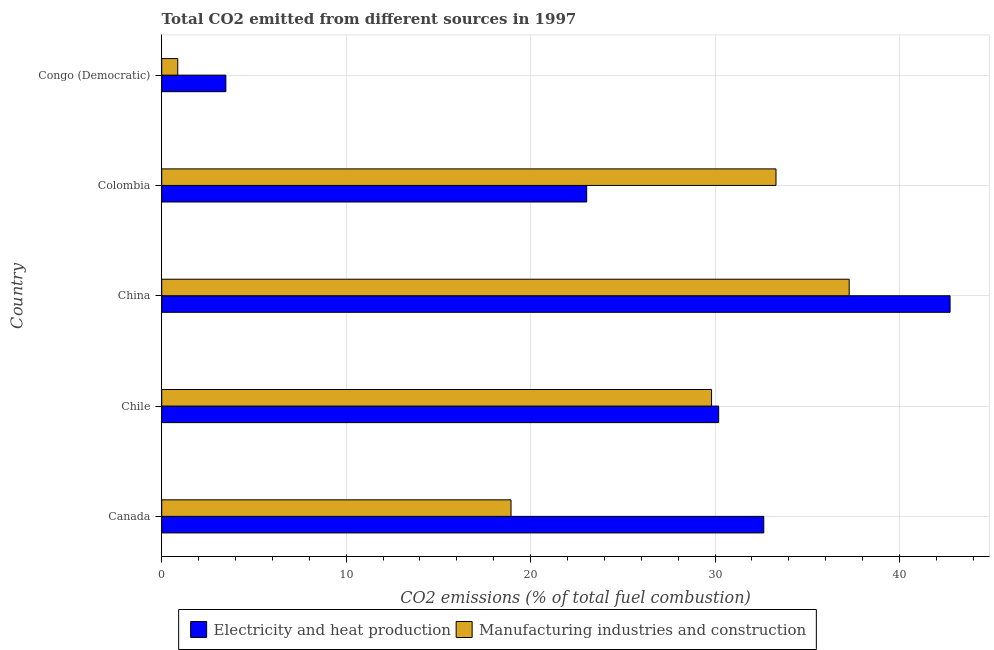How many different coloured bars are there?
Provide a short and direct response. 2. Are the number of bars per tick equal to the number of legend labels?
Keep it short and to the point. Yes. What is the co2 emissions due to manufacturing industries in Colombia?
Your response must be concise. 33.31. Across all countries, what is the maximum co2 emissions due to electricity and heat production?
Provide a short and direct response. 42.74. Across all countries, what is the minimum co2 emissions due to electricity and heat production?
Provide a short and direct response. 3.48. In which country was the co2 emissions due to electricity and heat production minimum?
Keep it short and to the point. Congo (Democratic). What is the total co2 emissions due to electricity and heat production in the graph?
Keep it short and to the point. 132.11. What is the difference between the co2 emissions due to electricity and heat production in Chile and that in China?
Your answer should be compact. -12.55. What is the difference between the co2 emissions due to electricity and heat production in Congo (Democratic) and the co2 emissions due to manufacturing industries in Canada?
Offer a terse response. -15.46. What is the average co2 emissions due to manufacturing industries per country?
Offer a very short reply. 24.04. What is the difference between the co2 emissions due to manufacturing industries and co2 emissions due to electricity and heat production in Colombia?
Offer a very short reply. 10.26. What is the ratio of the co2 emissions due to electricity and heat production in China to that in Congo (Democratic)?
Offer a terse response. 12.29. What is the difference between the highest and the second highest co2 emissions due to manufacturing industries?
Your answer should be compact. 3.97. What is the difference between the highest and the lowest co2 emissions due to manufacturing industries?
Provide a succinct answer. 36.41. What does the 2nd bar from the top in Colombia represents?
Ensure brevity in your answer.  Electricity and heat production. What does the 2nd bar from the bottom in Colombia represents?
Make the answer very short. Manufacturing industries and construction. How many bars are there?
Your response must be concise. 10. How many countries are there in the graph?
Your response must be concise. 5. Are the values on the major ticks of X-axis written in scientific E-notation?
Provide a short and direct response. No. Does the graph contain any zero values?
Your response must be concise. No. How many legend labels are there?
Your answer should be very brief. 2. What is the title of the graph?
Your answer should be very brief. Total CO2 emitted from different sources in 1997. What is the label or title of the X-axis?
Your answer should be compact. CO2 emissions (% of total fuel combustion). What is the CO2 emissions (% of total fuel combustion) of Electricity and heat production in Canada?
Ensure brevity in your answer.  32.64. What is the CO2 emissions (% of total fuel combustion) of Manufacturing industries and construction in Canada?
Offer a very short reply. 18.94. What is the CO2 emissions (% of total fuel combustion) in Electricity and heat production in Chile?
Your response must be concise. 30.2. What is the CO2 emissions (% of total fuel combustion) of Manufacturing industries and construction in Chile?
Provide a short and direct response. 29.81. What is the CO2 emissions (% of total fuel combustion) in Electricity and heat production in China?
Keep it short and to the point. 42.74. What is the CO2 emissions (% of total fuel combustion) in Manufacturing industries and construction in China?
Your answer should be very brief. 37.27. What is the CO2 emissions (% of total fuel combustion) of Electricity and heat production in Colombia?
Make the answer very short. 23.04. What is the CO2 emissions (% of total fuel combustion) in Manufacturing industries and construction in Colombia?
Provide a short and direct response. 33.31. What is the CO2 emissions (% of total fuel combustion) of Electricity and heat production in Congo (Democratic)?
Provide a succinct answer. 3.48. What is the CO2 emissions (% of total fuel combustion) of Manufacturing industries and construction in Congo (Democratic)?
Your response must be concise. 0.87. Across all countries, what is the maximum CO2 emissions (% of total fuel combustion) of Electricity and heat production?
Make the answer very short. 42.74. Across all countries, what is the maximum CO2 emissions (% of total fuel combustion) of Manufacturing industries and construction?
Give a very brief answer. 37.27. Across all countries, what is the minimum CO2 emissions (% of total fuel combustion) in Electricity and heat production?
Your response must be concise. 3.48. Across all countries, what is the minimum CO2 emissions (% of total fuel combustion) in Manufacturing industries and construction?
Provide a short and direct response. 0.87. What is the total CO2 emissions (% of total fuel combustion) in Electricity and heat production in the graph?
Provide a succinct answer. 132.11. What is the total CO2 emissions (% of total fuel combustion) in Manufacturing industries and construction in the graph?
Offer a very short reply. 120.2. What is the difference between the CO2 emissions (% of total fuel combustion) in Electricity and heat production in Canada and that in Chile?
Provide a short and direct response. 2.45. What is the difference between the CO2 emissions (% of total fuel combustion) of Manufacturing industries and construction in Canada and that in Chile?
Your answer should be very brief. -10.87. What is the difference between the CO2 emissions (% of total fuel combustion) in Electricity and heat production in Canada and that in China?
Offer a terse response. -10.1. What is the difference between the CO2 emissions (% of total fuel combustion) of Manufacturing industries and construction in Canada and that in China?
Your answer should be compact. -18.34. What is the difference between the CO2 emissions (% of total fuel combustion) in Electricity and heat production in Canada and that in Colombia?
Your response must be concise. 9.6. What is the difference between the CO2 emissions (% of total fuel combustion) in Manufacturing industries and construction in Canada and that in Colombia?
Your answer should be very brief. -14.37. What is the difference between the CO2 emissions (% of total fuel combustion) in Electricity and heat production in Canada and that in Congo (Democratic)?
Keep it short and to the point. 29.17. What is the difference between the CO2 emissions (% of total fuel combustion) of Manufacturing industries and construction in Canada and that in Congo (Democratic)?
Keep it short and to the point. 18.07. What is the difference between the CO2 emissions (% of total fuel combustion) in Electricity and heat production in Chile and that in China?
Give a very brief answer. -12.55. What is the difference between the CO2 emissions (% of total fuel combustion) of Manufacturing industries and construction in Chile and that in China?
Provide a short and direct response. -7.46. What is the difference between the CO2 emissions (% of total fuel combustion) in Electricity and heat production in Chile and that in Colombia?
Give a very brief answer. 7.16. What is the difference between the CO2 emissions (% of total fuel combustion) of Manufacturing industries and construction in Chile and that in Colombia?
Your answer should be compact. -3.49. What is the difference between the CO2 emissions (% of total fuel combustion) in Electricity and heat production in Chile and that in Congo (Democratic)?
Keep it short and to the point. 26.72. What is the difference between the CO2 emissions (% of total fuel combustion) in Manufacturing industries and construction in Chile and that in Congo (Democratic)?
Ensure brevity in your answer.  28.94. What is the difference between the CO2 emissions (% of total fuel combustion) in Electricity and heat production in China and that in Colombia?
Keep it short and to the point. 19.7. What is the difference between the CO2 emissions (% of total fuel combustion) of Manufacturing industries and construction in China and that in Colombia?
Your answer should be very brief. 3.97. What is the difference between the CO2 emissions (% of total fuel combustion) in Electricity and heat production in China and that in Congo (Democratic)?
Give a very brief answer. 39.27. What is the difference between the CO2 emissions (% of total fuel combustion) of Manufacturing industries and construction in China and that in Congo (Democratic)?
Offer a very short reply. 36.41. What is the difference between the CO2 emissions (% of total fuel combustion) of Electricity and heat production in Colombia and that in Congo (Democratic)?
Give a very brief answer. 19.56. What is the difference between the CO2 emissions (% of total fuel combustion) of Manufacturing industries and construction in Colombia and that in Congo (Democratic)?
Your response must be concise. 32.44. What is the difference between the CO2 emissions (% of total fuel combustion) of Electricity and heat production in Canada and the CO2 emissions (% of total fuel combustion) of Manufacturing industries and construction in Chile?
Keep it short and to the point. 2.83. What is the difference between the CO2 emissions (% of total fuel combustion) in Electricity and heat production in Canada and the CO2 emissions (% of total fuel combustion) in Manufacturing industries and construction in China?
Offer a very short reply. -4.63. What is the difference between the CO2 emissions (% of total fuel combustion) of Electricity and heat production in Canada and the CO2 emissions (% of total fuel combustion) of Manufacturing industries and construction in Colombia?
Your answer should be compact. -0.66. What is the difference between the CO2 emissions (% of total fuel combustion) in Electricity and heat production in Canada and the CO2 emissions (% of total fuel combustion) in Manufacturing industries and construction in Congo (Democratic)?
Offer a terse response. 31.77. What is the difference between the CO2 emissions (% of total fuel combustion) in Electricity and heat production in Chile and the CO2 emissions (% of total fuel combustion) in Manufacturing industries and construction in China?
Offer a very short reply. -7.08. What is the difference between the CO2 emissions (% of total fuel combustion) in Electricity and heat production in Chile and the CO2 emissions (% of total fuel combustion) in Manufacturing industries and construction in Colombia?
Your response must be concise. -3.11. What is the difference between the CO2 emissions (% of total fuel combustion) in Electricity and heat production in Chile and the CO2 emissions (% of total fuel combustion) in Manufacturing industries and construction in Congo (Democratic)?
Your answer should be compact. 29.33. What is the difference between the CO2 emissions (% of total fuel combustion) in Electricity and heat production in China and the CO2 emissions (% of total fuel combustion) in Manufacturing industries and construction in Colombia?
Your response must be concise. 9.44. What is the difference between the CO2 emissions (% of total fuel combustion) in Electricity and heat production in China and the CO2 emissions (% of total fuel combustion) in Manufacturing industries and construction in Congo (Democratic)?
Provide a short and direct response. 41.88. What is the difference between the CO2 emissions (% of total fuel combustion) of Electricity and heat production in Colombia and the CO2 emissions (% of total fuel combustion) of Manufacturing industries and construction in Congo (Democratic)?
Offer a terse response. 22.17. What is the average CO2 emissions (% of total fuel combustion) of Electricity and heat production per country?
Your response must be concise. 26.42. What is the average CO2 emissions (% of total fuel combustion) of Manufacturing industries and construction per country?
Offer a very short reply. 24.04. What is the difference between the CO2 emissions (% of total fuel combustion) in Electricity and heat production and CO2 emissions (% of total fuel combustion) in Manufacturing industries and construction in Canada?
Give a very brief answer. 13.7. What is the difference between the CO2 emissions (% of total fuel combustion) in Electricity and heat production and CO2 emissions (% of total fuel combustion) in Manufacturing industries and construction in Chile?
Offer a very short reply. 0.39. What is the difference between the CO2 emissions (% of total fuel combustion) of Electricity and heat production and CO2 emissions (% of total fuel combustion) of Manufacturing industries and construction in China?
Provide a succinct answer. 5.47. What is the difference between the CO2 emissions (% of total fuel combustion) of Electricity and heat production and CO2 emissions (% of total fuel combustion) of Manufacturing industries and construction in Colombia?
Your response must be concise. -10.26. What is the difference between the CO2 emissions (% of total fuel combustion) of Electricity and heat production and CO2 emissions (% of total fuel combustion) of Manufacturing industries and construction in Congo (Democratic)?
Keep it short and to the point. 2.61. What is the ratio of the CO2 emissions (% of total fuel combustion) of Electricity and heat production in Canada to that in Chile?
Offer a terse response. 1.08. What is the ratio of the CO2 emissions (% of total fuel combustion) of Manufacturing industries and construction in Canada to that in Chile?
Offer a very short reply. 0.64. What is the ratio of the CO2 emissions (% of total fuel combustion) of Electricity and heat production in Canada to that in China?
Provide a succinct answer. 0.76. What is the ratio of the CO2 emissions (% of total fuel combustion) of Manufacturing industries and construction in Canada to that in China?
Keep it short and to the point. 0.51. What is the ratio of the CO2 emissions (% of total fuel combustion) in Electricity and heat production in Canada to that in Colombia?
Offer a terse response. 1.42. What is the ratio of the CO2 emissions (% of total fuel combustion) in Manufacturing industries and construction in Canada to that in Colombia?
Your response must be concise. 0.57. What is the ratio of the CO2 emissions (% of total fuel combustion) of Electricity and heat production in Canada to that in Congo (Democratic)?
Give a very brief answer. 9.39. What is the ratio of the CO2 emissions (% of total fuel combustion) in Manufacturing industries and construction in Canada to that in Congo (Democratic)?
Provide a short and direct response. 21.78. What is the ratio of the CO2 emissions (% of total fuel combustion) of Electricity and heat production in Chile to that in China?
Make the answer very short. 0.71. What is the ratio of the CO2 emissions (% of total fuel combustion) of Manufacturing industries and construction in Chile to that in China?
Offer a terse response. 0.8. What is the ratio of the CO2 emissions (% of total fuel combustion) in Electricity and heat production in Chile to that in Colombia?
Provide a succinct answer. 1.31. What is the ratio of the CO2 emissions (% of total fuel combustion) in Manufacturing industries and construction in Chile to that in Colombia?
Your answer should be compact. 0.9. What is the ratio of the CO2 emissions (% of total fuel combustion) of Electricity and heat production in Chile to that in Congo (Democratic)?
Your answer should be very brief. 8.68. What is the ratio of the CO2 emissions (% of total fuel combustion) of Manufacturing industries and construction in Chile to that in Congo (Democratic)?
Keep it short and to the point. 34.28. What is the ratio of the CO2 emissions (% of total fuel combustion) of Electricity and heat production in China to that in Colombia?
Offer a very short reply. 1.85. What is the ratio of the CO2 emissions (% of total fuel combustion) in Manufacturing industries and construction in China to that in Colombia?
Provide a short and direct response. 1.12. What is the ratio of the CO2 emissions (% of total fuel combustion) in Electricity and heat production in China to that in Congo (Democratic)?
Your answer should be very brief. 12.29. What is the ratio of the CO2 emissions (% of total fuel combustion) of Manufacturing industries and construction in China to that in Congo (Democratic)?
Offer a terse response. 42.87. What is the ratio of the CO2 emissions (% of total fuel combustion) of Electricity and heat production in Colombia to that in Congo (Democratic)?
Your response must be concise. 6.62. What is the ratio of the CO2 emissions (% of total fuel combustion) of Manufacturing industries and construction in Colombia to that in Congo (Democratic)?
Offer a terse response. 38.3. What is the difference between the highest and the second highest CO2 emissions (% of total fuel combustion) in Electricity and heat production?
Offer a very short reply. 10.1. What is the difference between the highest and the second highest CO2 emissions (% of total fuel combustion) of Manufacturing industries and construction?
Your answer should be very brief. 3.97. What is the difference between the highest and the lowest CO2 emissions (% of total fuel combustion) of Electricity and heat production?
Offer a very short reply. 39.27. What is the difference between the highest and the lowest CO2 emissions (% of total fuel combustion) in Manufacturing industries and construction?
Ensure brevity in your answer.  36.41. 